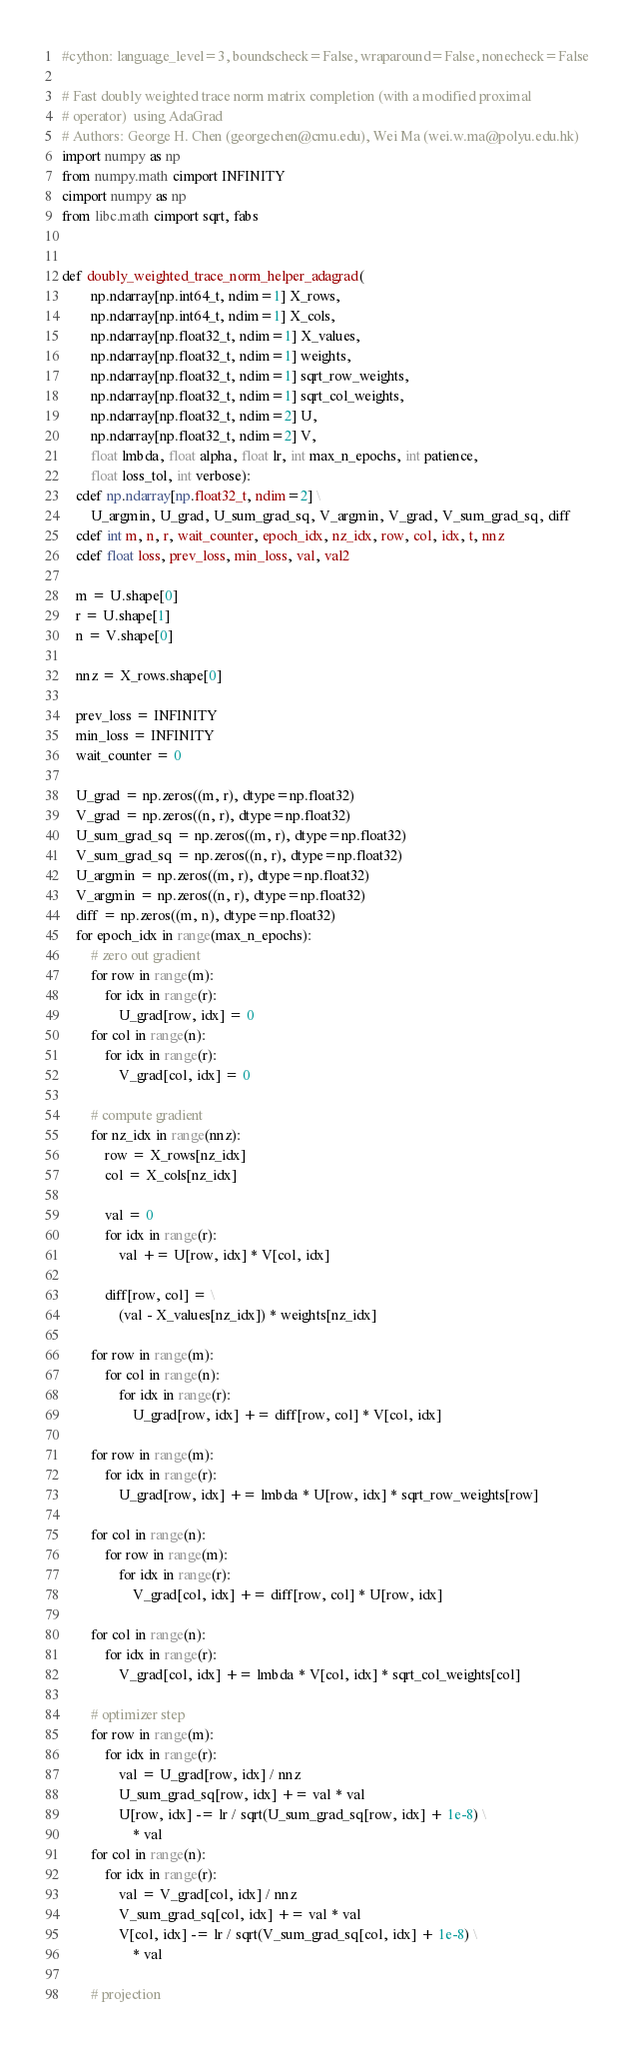<code> <loc_0><loc_0><loc_500><loc_500><_Cython_>#cython: language_level=3, boundscheck=False, wraparound=False, nonecheck=False

# Fast doubly weighted trace norm matrix completion (with a modified proximal
# operator)  using AdaGrad
# Authors: George H. Chen (georgechen@cmu.edu), Wei Ma (wei.w.ma@polyu.edu.hk)
import numpy as np
from numpy.math cimport INFINITY
cimport numpy as np
from libc.math cimport sqrt, fabs


def doubly_weighted_trace_norm_helper_adagrad(
        np.ndarray[np.int64_t, ndim=1] X_rows,
        np.ndarray[np.int64_t, ndim=1] X_cols,
        np.ndarray[np.float32_t, ndim=1] X_values,
        np.ndarray[np.float32_t, ndim=1] weights,
        np.ndarray[np.float32_t, ndim=1] sqrt_row_weights,
        np.ndarray[np.float32_t, ndim=1] sqrt_col_weights,
        np.ndarray[np.float32_t, ndim=2] U,
        np.ndarray[np.float32_t, ndim=2] V,
        float lmbda, float alpha, float lr, int max_n_epochs, int patience,
        float loss_tol, int verbose):
    cdef np.ndarray[np.float32_t, ndim=2] \
        U_argmin, U_grad, U_sum_grad_sq, V_argmin, V_grad, V_sum_grad_sq, diff
    cdef int m, n, r, wait_counter, epoch_idx, nz_idx, row, col, idx, t, nnz
    cdef float loss, prev_loss, min_loss, val, val2

    m = U.shape[0]
    r = U.shape[1]
    n = V.shape[0]

    nnz = X_rows.shape[0]

    prev_loss = INFINITY
    min_loss = INFINITY
    wait_counter = 0

    U_grad = np.zeros((m, r), dtype=np.float32)
    V_grad = np.zeros((n, r), dtype=np.float32)
    U_sum_grad_sq = np.zeros((m, r), dtype=np.float32)
    V_sum_grad_sq = np.zeros((n, r), dtype=np.float32)
    U_argmin = np.zeros((m, r), dtype=np.float32)
    V_argmin = np.zeros((n, r), dtype=np.float32)
    diff = np.zeros((m, n), dtype=np.float32)
    for epoch_idx in range(max_n_epochs):
        # zero out gradient
        for row in range(m):
            for idx in range(r):
                U_grad[row, idx] = 0
        for col in range(n):
            for idx in range(r):
                V_grad[col, idx] = 0

        # compute gradient
        for nz_idx in range(nnz):
            row = X_rows[nz_idx]
            col = X_cols[nz_idx]

            val = 0
            for idx in range(r):
                val += U[row, idx] * V[col, idx]

            diff[row, col] = \
                (val - X_values[nz_idx]) * weights[nz_idx]

        for row in range(m):
            for col in range(n):
                for idx in range(r):
                    U_grad[row, idx] += diff[row, col] * V[col, idx]

        for row in range(m):
            for idx in range(r):
                U_grad[row, idx] += lmbda * U[row, idx] * sqrt_row_weights[row]

        for col in range(n):
            for row in range(m):
                for idx in range(r):
                    V_grad[col, idx] += diff[row, col] * U[row, idx]

        for col in range(n):
            for idx in range(r):
                V_grad[col, idx] += lmbda * V[col, idx] * sqrt_col_weights[col]

        # optimizer step
        for row in range(m):
            for idx in range(r):
                val = U_grad[row, idx] / nnz
                U_sum_grad_sq[row, idx] += val * val
                U[row, idx] -= lr / sqrt(U_sum_grad_sq[row, idx] + 1e-8) \
                    * val
        for col in range(n):
            for idx in range(r):
                val = V_grad[col, idx] / nnz
                V_sum_grad_sq[col, idx] += val * val
                V[col, idx] -= lr / sqrt(V_sum_grad_sq[col, idx] + 1e-8) \
                    * val

        # projection</code> 